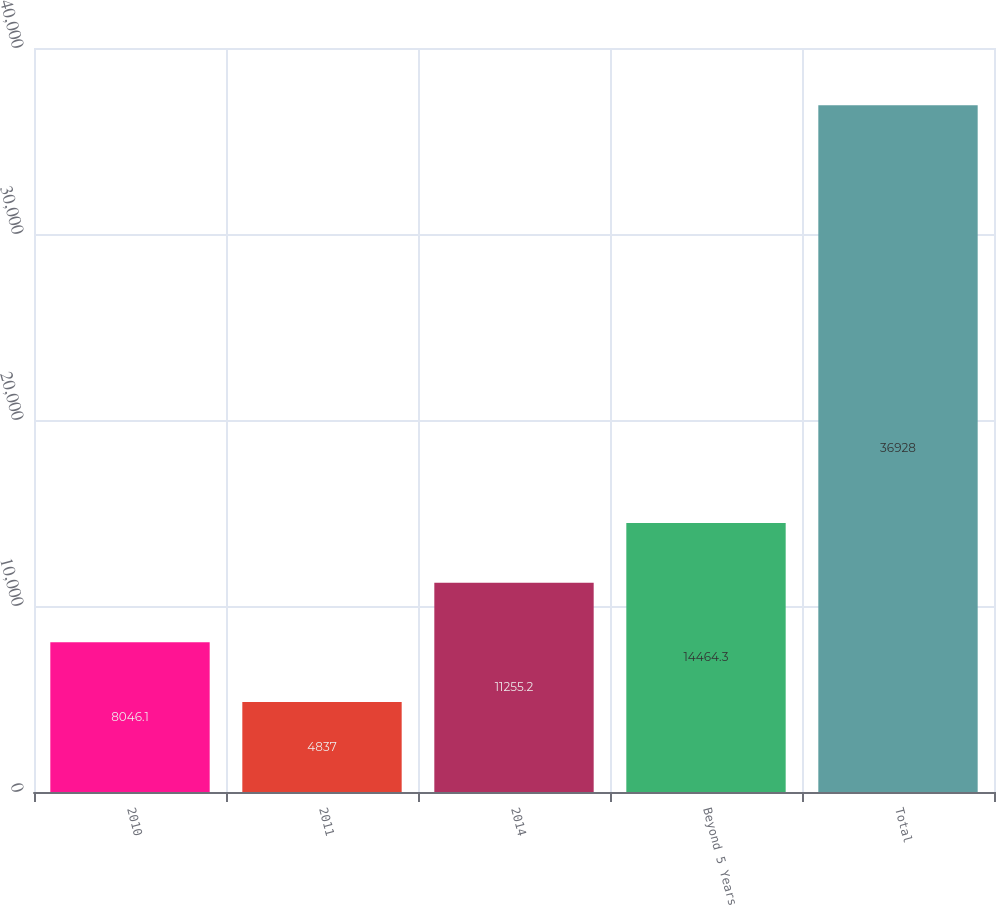<chart> <loc_0><loc_0><loc_500><loc_500><bar_chart><fcel>2010<fcel>2011<fcel>2014<fcel>Beyond 5 Years<fcel>Total<nl><fcel>8046.1<fcel>4837<fcel>11255.2<fcel>14464.3<fcel>36928<nl></chart> 